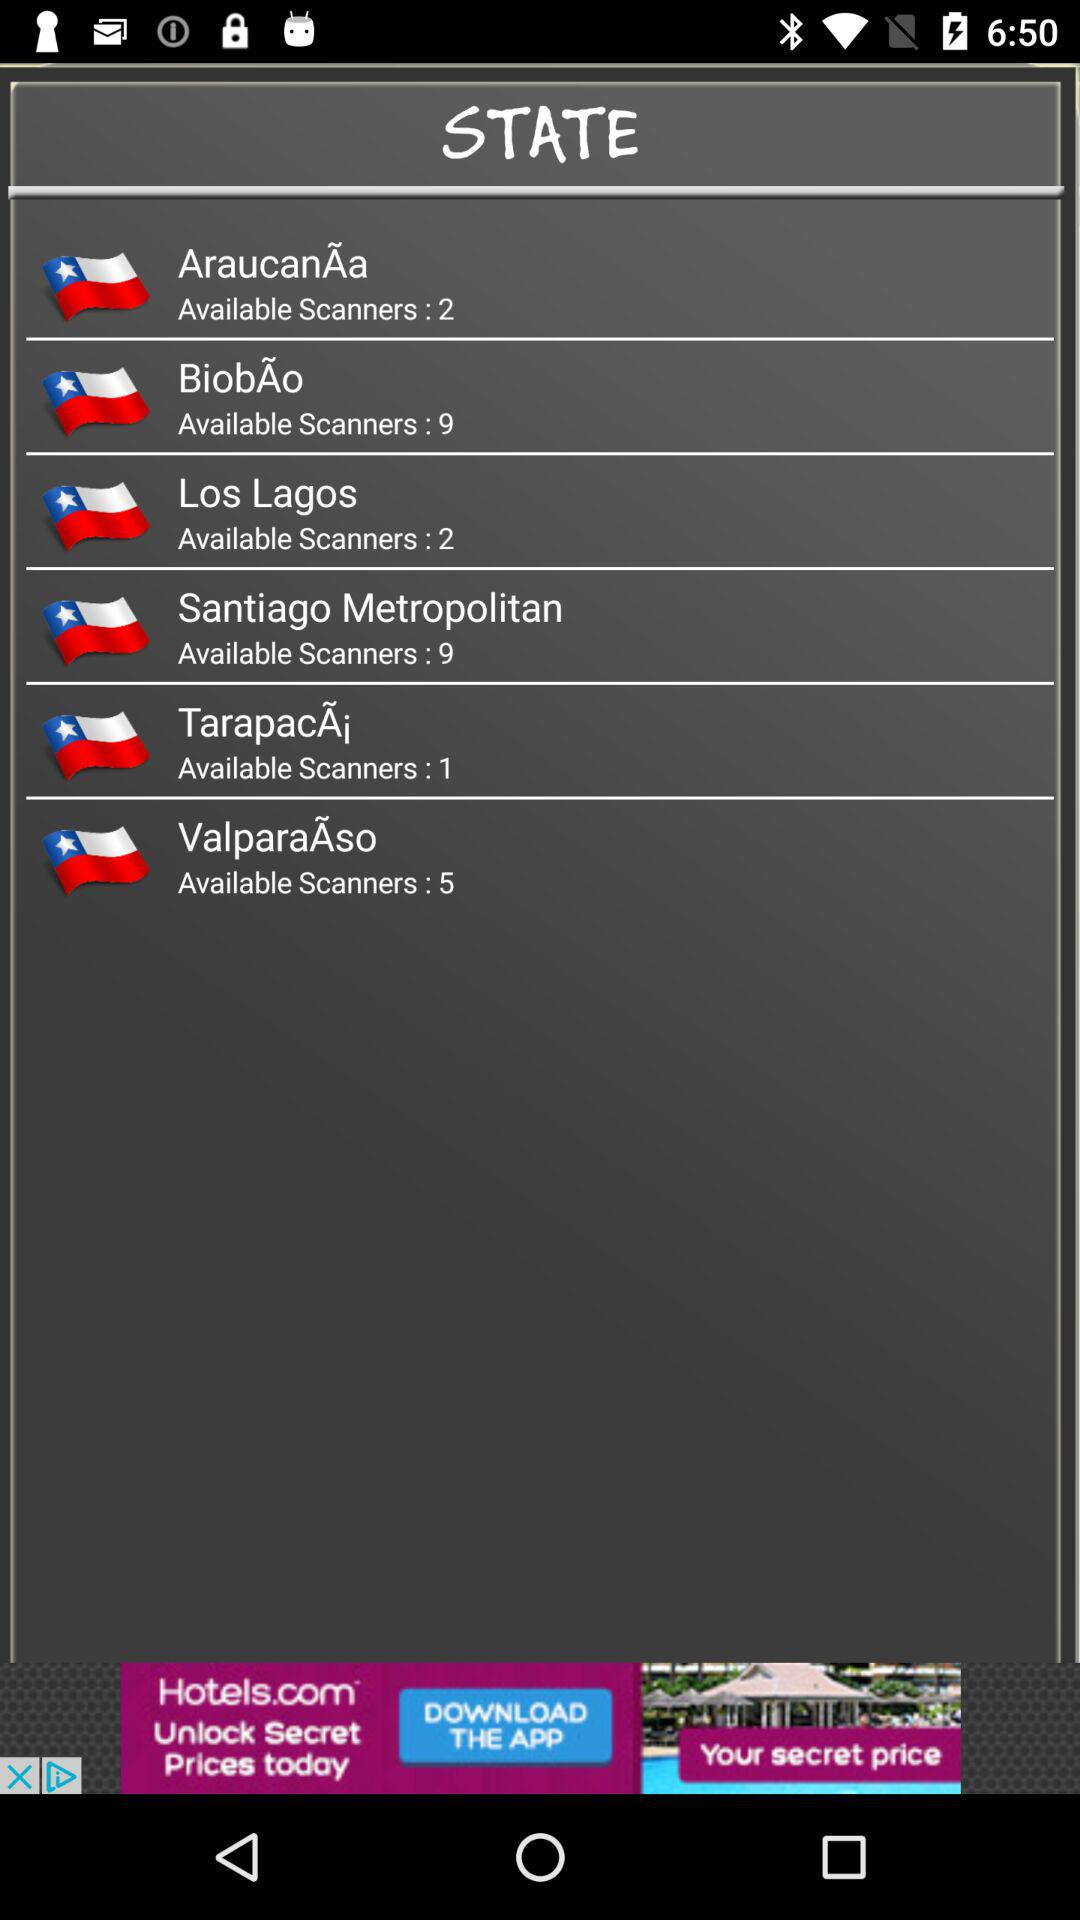How many scanners are available for Los Lagos? There are 2 scanners available. 